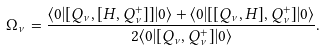<formula> <loc_0><loc_0><loc_500><loc_500>\Omega _ { \nu } = \frac { \langle 0 | [ Q _ { \nu } , [ H , Q _ { \nu } ^ { + } ] ] | 0 \rangle + \langle 0 | [ [ Q _ { \nu } , H ] , Q _ { \nu } ^ { + } ] | 0 \rangle } { 2 \langle 0 | [ Q _ { \nu } , Q _ { \nu } ^ { + } ] | 0 \rangle } .</formula> 